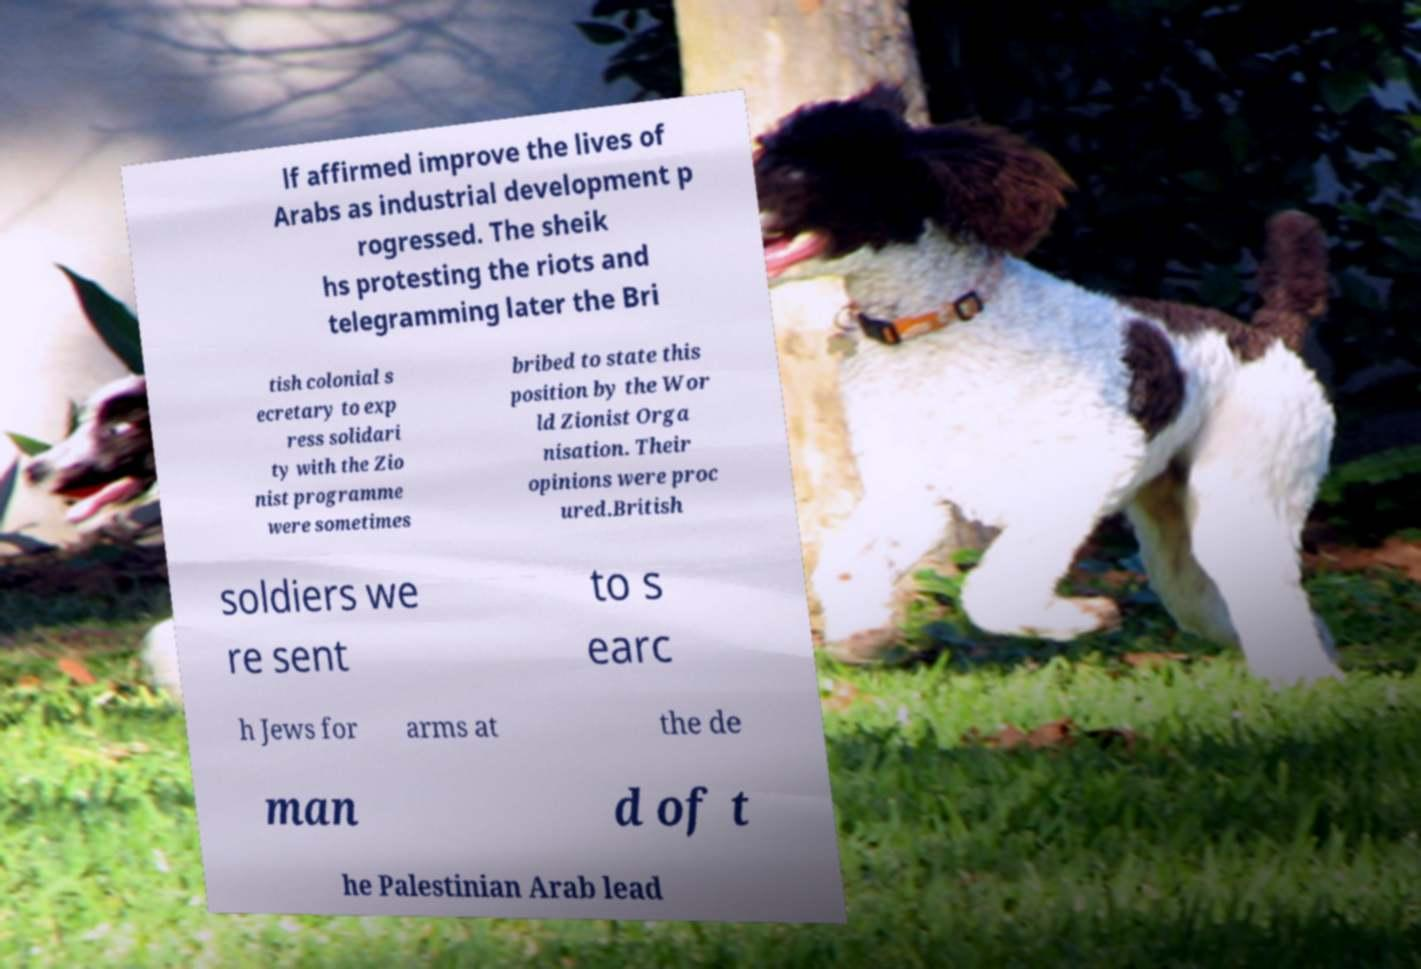There's text embedded in this image that I need extracted. Can you transcribe it verbatim? lf affirmed improve the lives of Arabs as industrial development p rogressed. The sheik hs protesting the riots and telegramming later the Bri tish colonial s ecretary to exp ress solidari ty with the Zio nist programme were sometimes bribed to state this position by the Wor ld Zionist Orga nisation. Their opinions were proc ured.British soldiers we re sent to s earc h Jews for arms at the de man d of t he Palestinian Arab lead 